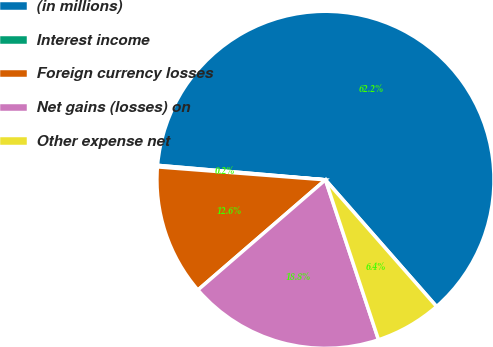Convert chart to OTSL. <chart><loc_0><loc_0><loc_500><loc_500><pie_chart><fcel>(in millions)<fcel>Interest income<fcel>Foreign currency losses<fcel>Net gains (losses) on<fcel>Other expense net<nl><fcel>62.17%<fcel>0.15%<fcel>12.56%<fcel>18.76%<fcel>6.36%<nl></chart> 